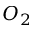Convert formula to latex. <formula><loc_0><loc_0><loc_500><loc_500>O _ { 2 }</formula> 